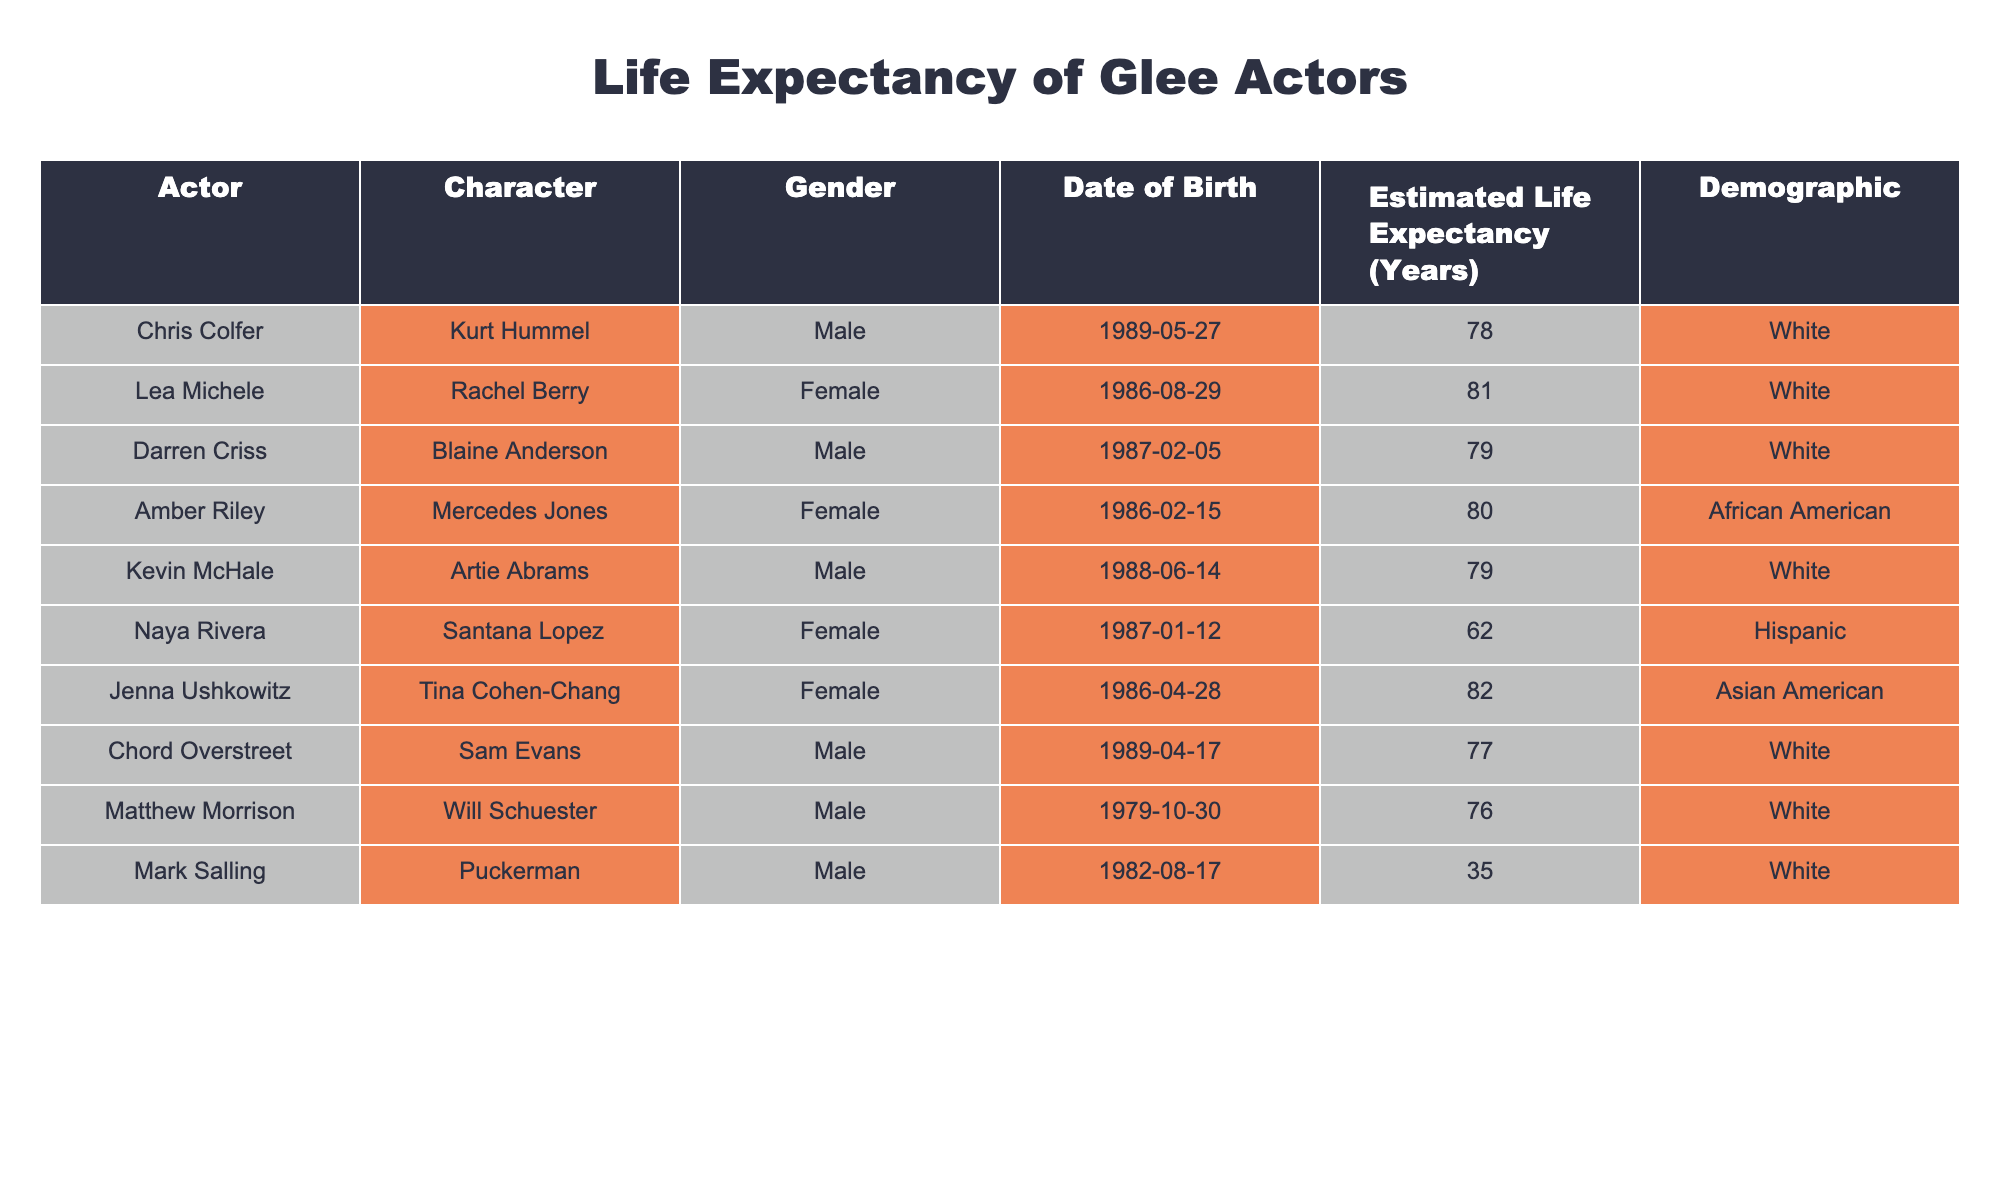What is the estimated life expectancy of Chris Colfer? The table lists the estimated life expectancy of Chris Colfer, who is identified as playing Kurt Hummel. According to the table, his estimated life expectancy is 78 years.
Answer: 78 Which actor has the lowest estimated life expectancy? By reviewing the column of estimated life expectancy values, it can be seen that Mark Salling has the lowest estimated life expectancy of 35 years.
Answer: 35 What is the average estimated life expectancy of the female actors? To find the average estimated life expectancy of Female actors, we will first sum the life expectancies: Lea Michele (81) + Amber Riley (80) + Naya Rivera (62) + Jenna Ushkowitz (82) = 305. There are 4 Female actors, so the average is 305 / 4 = 76.25.
Answer: 76.25 Do all the actors in the table have an estimated life expectancy over 70? Analyzing the estimated life expectancy values, we find that Mark Salling has an estimated life expectancy of 35 years, which is below 70. Thus, not all actors have an estimated life expectancy over 70.
Answer: No Which demographic has the highest average estimated life expectancy among the actors? To determine which demographic has the highest average life expectancy, we calculate the averages for each demographic: White (78.25), African American (80), Hispanic (62), Asian American (82). The highest average is for Asian American, which is 82 years.
Answer: Asian American 